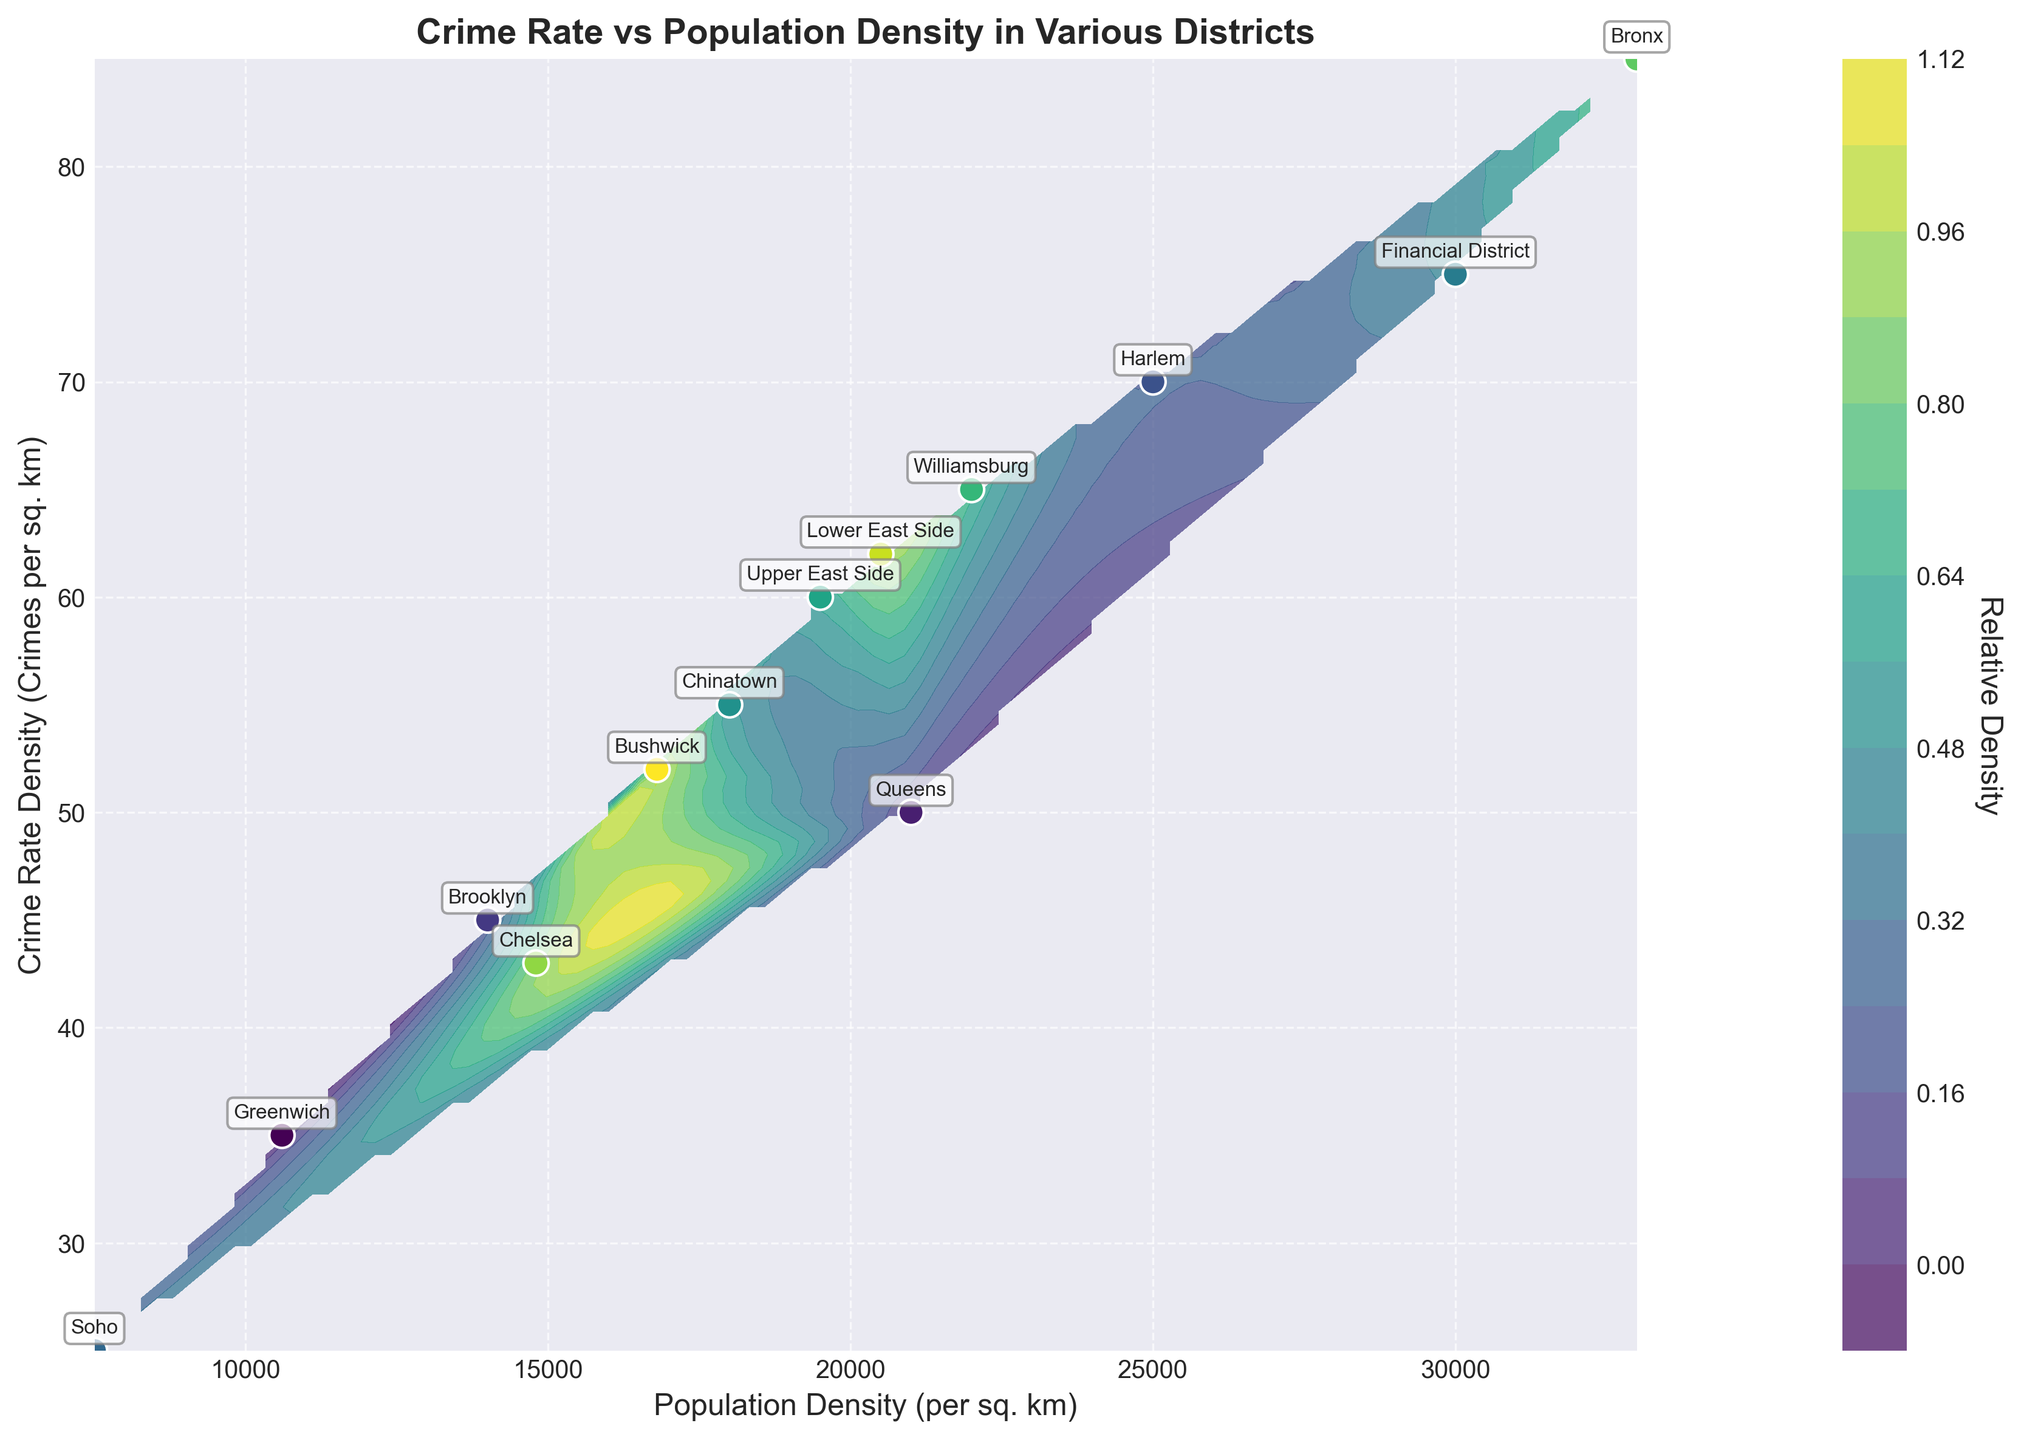What is the title of the plot? The title of the plot is typically found at the top of the chart and summarizes the main topic or relationship being visualized. In this case, it tells us that the plot is about the crime rate versus population density in various districts.
Answer: Crime Rate vs Population Density in Various Districts What are the axes labels on the plot? Axes labels provide information about the type of data represented along the X and Y axes. Here, the X-axis label indicates "Population Density (per sq. km)," and the Y-axis label indicates "Crime Rate Density (Crimes per sq. km)."
Answer: Population Density (per sq. km), Crime Rate Density (Crimes per sq. km) How many districts are labeled in the plot? To determine the number of districts, count how many unique labels are displayed in the plot. There are labeled points for each distinct district in the dataset.
Answer: 13 Which district has the highest crime rate density? The district with the highest crime rate density can be identified by locating the point that is situated highest along the Y-axis. In this plot, it is the Bronx with a crime rate density of 85.
Answer: Bronx Which districts have a population density higher than 20,000 per sq. km? To find districts with a population density higher than 20,000, look for points along the X-axis that are beyond the 20,000 mark. The districts that meet this criterion are Harlem, Financial District, Williamsburg, Lower East Side, and Bronx.
Answer: Harlem, Financial District, Williamsburg, Lower East Side, Bronx What is the relative density of crime rate for Chinatown district? Relative density can be inferred from contour lines and the color shading on the plot. Look at the point for Chinatown and check its color relative to the color bar. Chinatown is in a medium color shade, indicating moderate density.
Answer: Moderate density Which district appears to have the lowest crime rate density? Locate the district positioned lowest along the Y-axis which represents the crime rate density. Soho has the lowest crime rate density of 25.
Answer: Soho Is there a correlation between population density and crime rate density? By observing the overall trend and contours, note if there’s a relationship visible from the plot. Generally, as population density increases, the crime rate density also tends to increase, indicating a positive correlation.
Answer: Positive correlation Compare the crime rate density between Greenwich and Chelsea. Which has a higher rate? Check the Y-axis positions of Greenwich and Chelsea. Chelsea's crime rate density point (43) is slightly higher than Greenwich's (35).
Answer: Chelsea Which district has a population density closest to the average of the highest and lowest population densities? First calculate the average of the highest (Bronx, 33,000) and lowest (Soho, 7,500) population densities: (33,000 + 7,500)/2 = 20,250. Then identify the district closest to 20,250 along the X-axis, which is Upper East Side at 19,500.
Answer: Upper East Side 